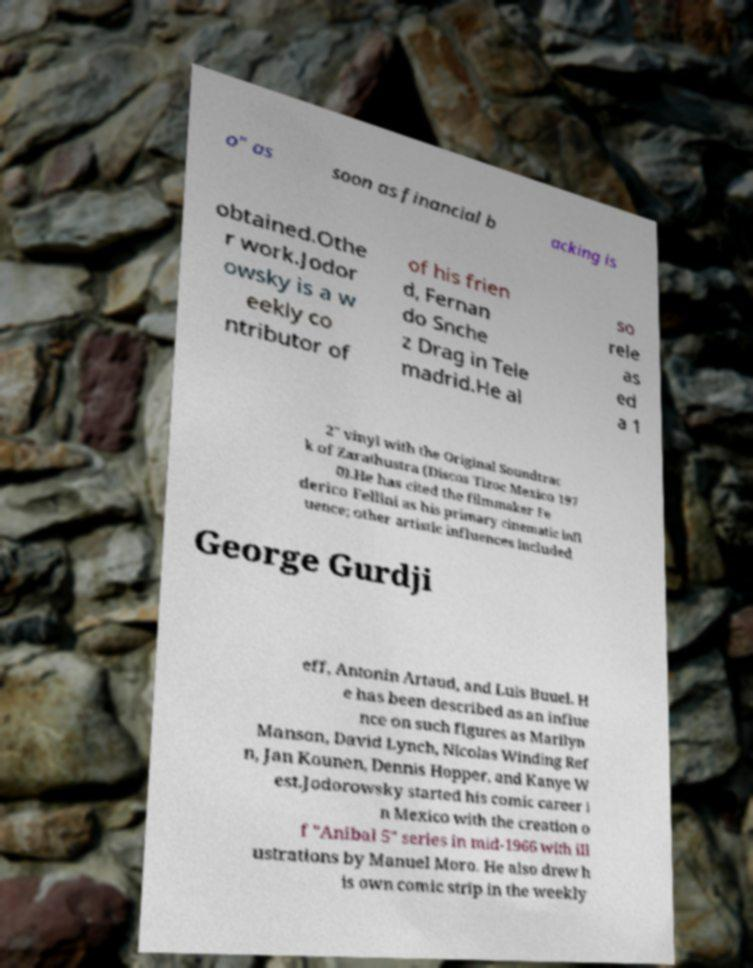I need the written content from this picture converted into text. Can you do that? o" as soon as financial b acking is obtained.Othe r work.Jodor owsky is a w eekly co ntributor of of his frien d, Fernan do Snche z Drag in Tele madrid.He al so rele as ed a 1 2" vinyl with the Original Soundtrac k of Zarathustra (Discos Tizoc Mexico 197 0).He has cited the filmmaker Fe derico Fellini as his primary cinematic infl uence; other artistic influences included George Gurdji eff, Antonin Artaud, and Luis Buuel. H e has been described as an influe nce on such figures as Marilyn Manson, David Lynch, Nicolas Winding Ref n, Jan Kounen, Dennis Hopper, and Kanye W est.Jodorowsky started his comic career i n Mexico with the creation o f "Anibal 5" series in mid-1966 with ill ustrations by Manuel Moro. He also drew h is own comic strip in the weekly 